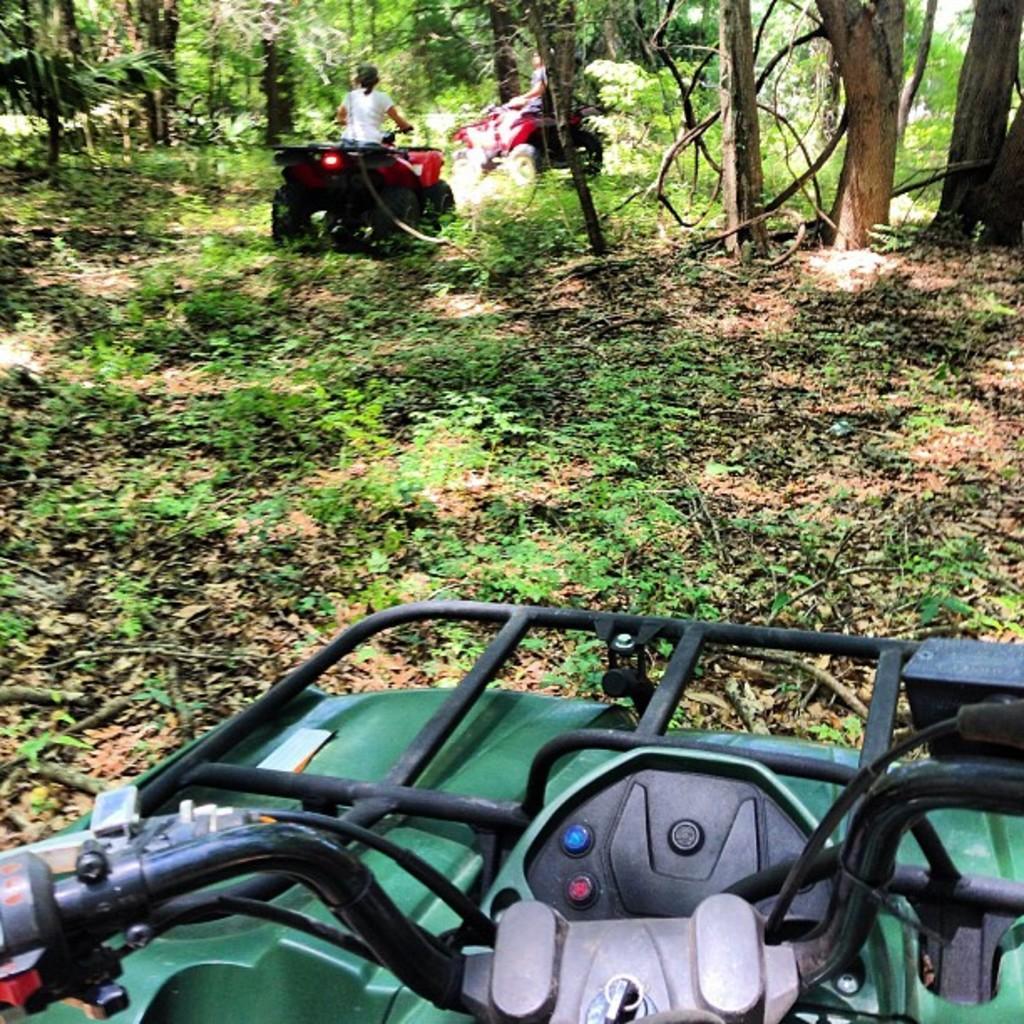Can you describe this image briefly? As we can see in the image there is grass, trees, vehicles and a person over here. 